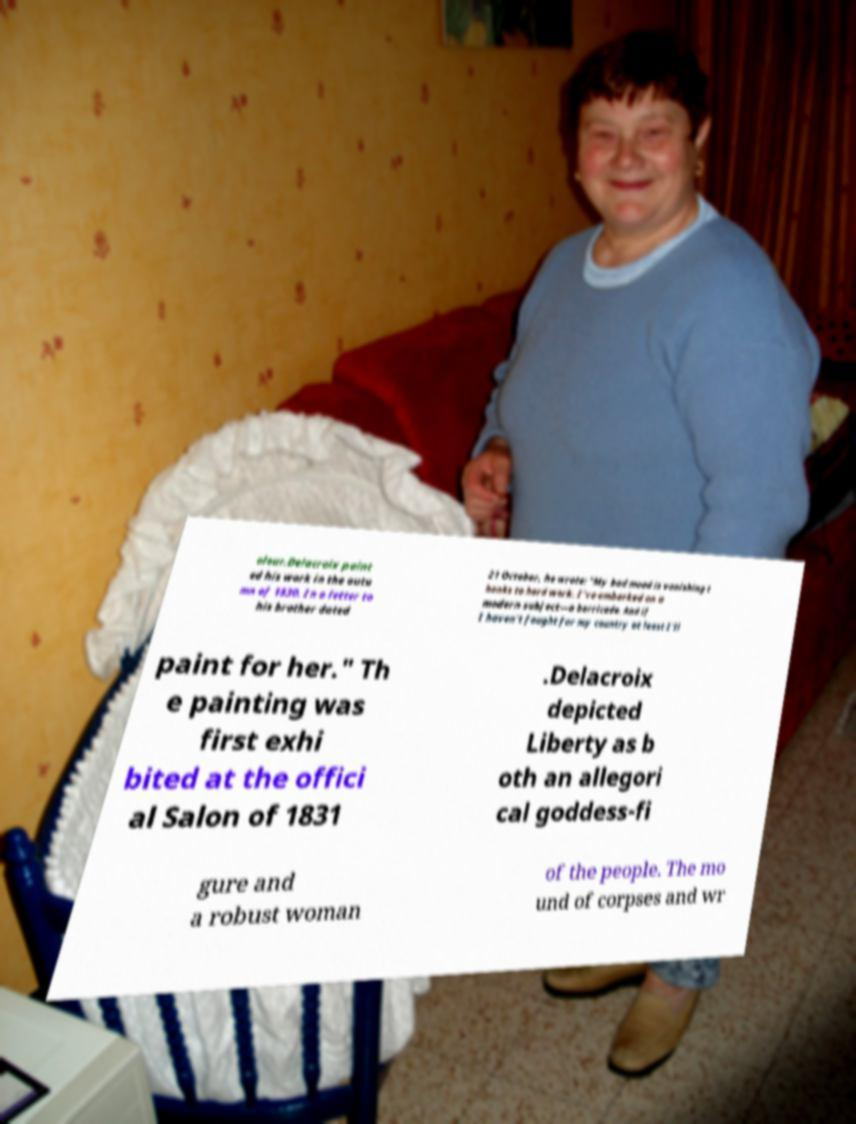I need the written content from this picture converted into text. Can you do that? olour.Delacroix paint ed his work in the autu mn of 1830. In a letter to his brother dated 21 October, he wrote: "My bad mood is vanishing t hanks to hard work. I've embarked on a modern subject—a barricade. And if I haven't fought for my country at least I'll paint for her." Th e painting was first exhi bited at the offici al Salon of 1831 .Delacroix depicted Liberty as b oth an allegori cal goddess-fi gure and a robust woman of the people. The mo und of corpses and wr 